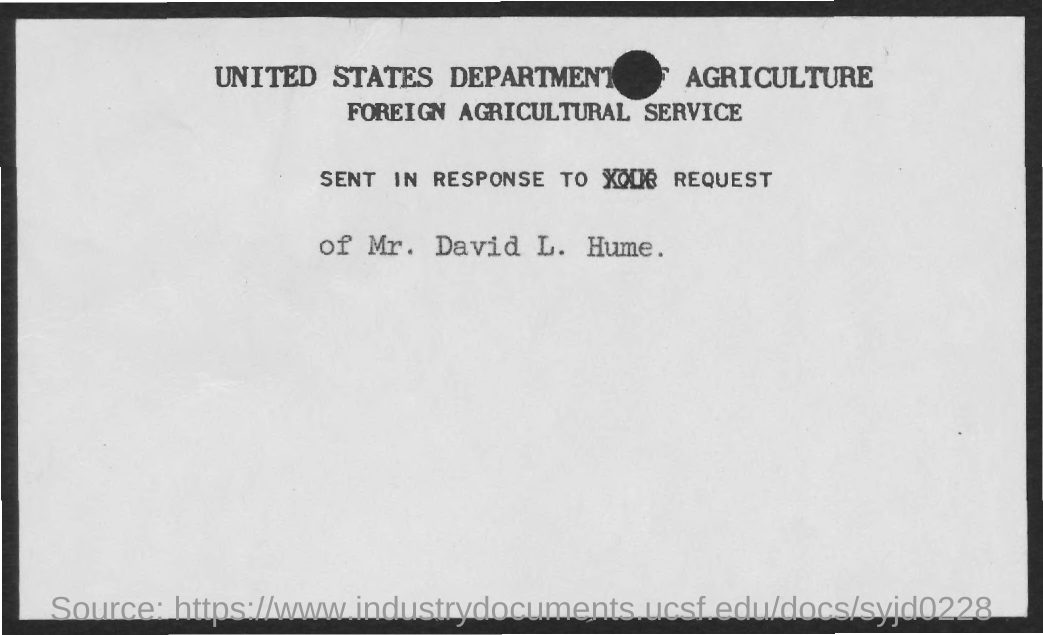Outline some significant characteristics in this image. The second title in the document is 'Foreign Agricultural Service.' 